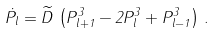<formula> <loc_0><loc_0><loc_500><loc_500>\dot { P } _ { l } = \widetilde { D } \, \left ( P _ { l + 1 } ^ { 3 } - 2 P _ { l } ^ { 3 } + P _ { l - 1 } ^ { 3 } \right ) \, .</formula> 